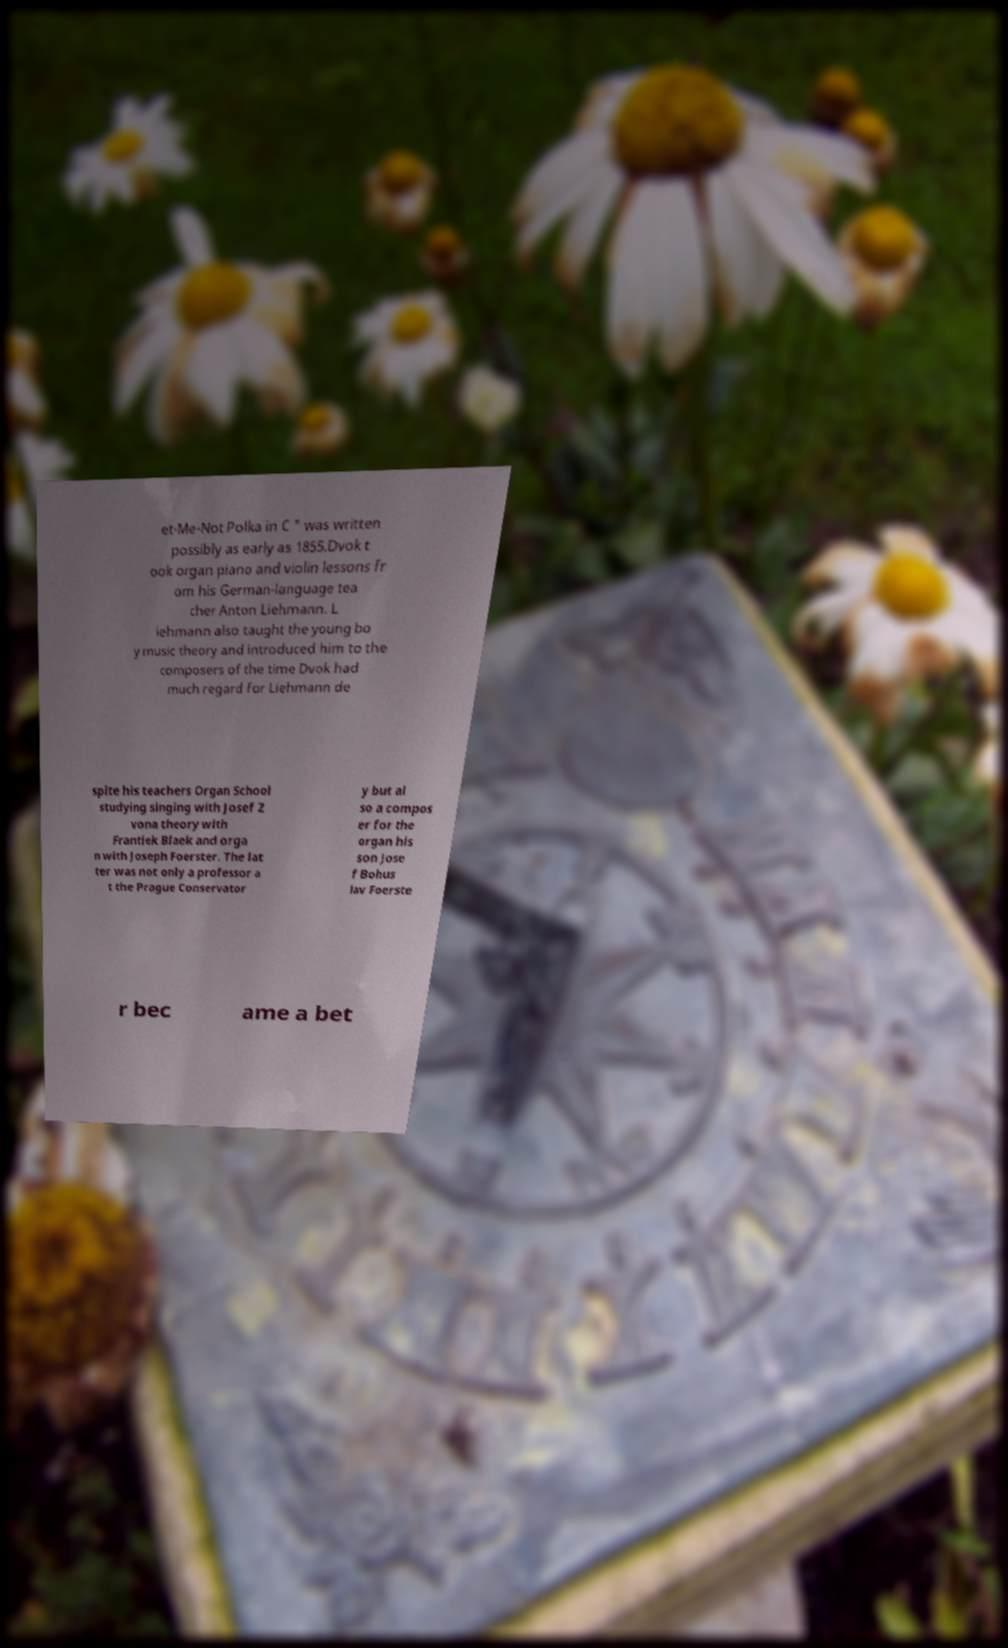Can you accurately transcribe the text from the provided image for me? et-Me-Not Polka in C " was written possibly as early as 1855.Dvok t ook organ piano and violin lessons fr om his German-language tea cher Anton Liehmann. L iehmann also taught the young bo y music theory and introduced him to the composers of the time Dvok had much regard for Liehmann de spite his teachers Organ School studying singing with Josef Z vona theory with Frantiek Blaek and orga n with Joseph Foerster. The lat ter was not only a professor a t the Prague Conservator y but al so a compos er for the organ his son Jose f Bohus lav Foerste r bec ame a bet 